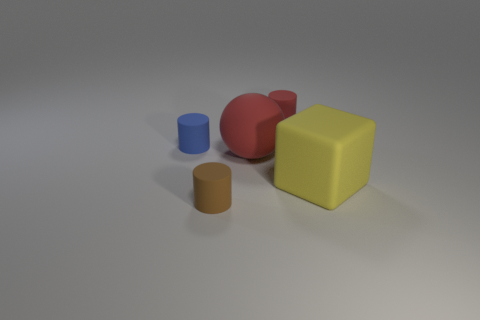Add 5 large red objects. How many objects exist? 10 Subtract all balls. How many objects are left? 4 Add 2 yellow rubber things. How many yellow rubber things are left? 3 Add 3 big cyan rubber cubes. How many big cyan rubber cubes exist? 3 Subtract 0 yellow cylinders. How many objects are left? 5 Subtract all large yellow rubber cubes. Subtract all large yellow rubber cubes. How many objects are left? 3 